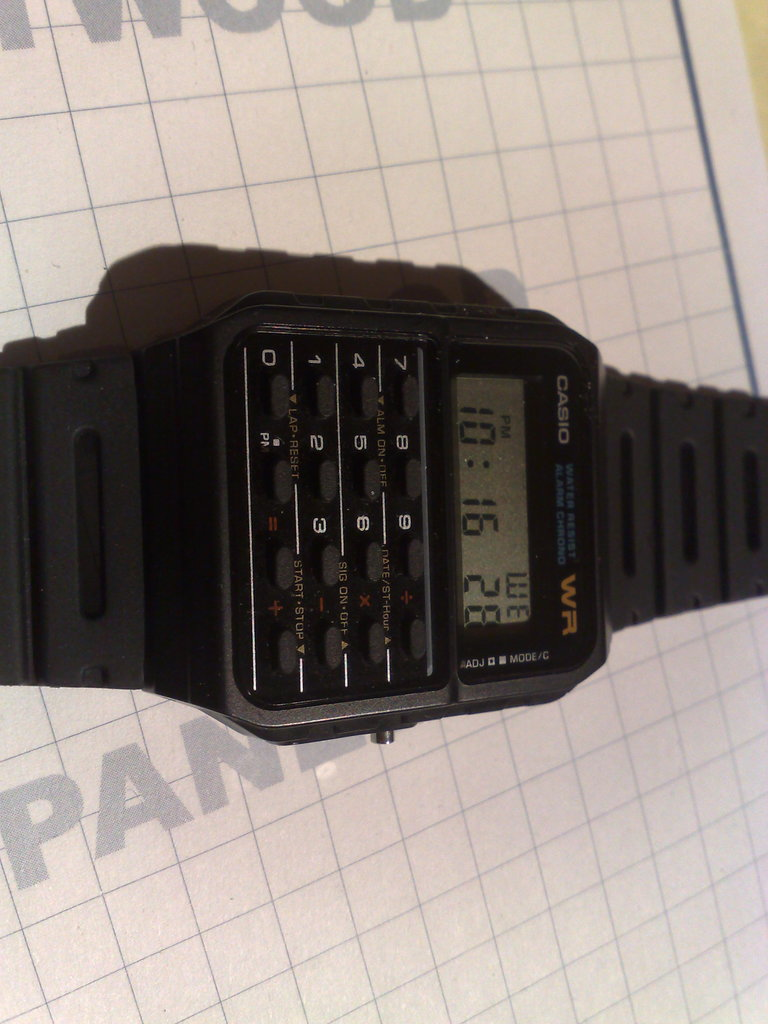Provide a one-sentence caption for the provided image. A vintage CASIO calculator watch, showcasing a multi-functional design with a keypad for mathematical operations and a digital time display. 